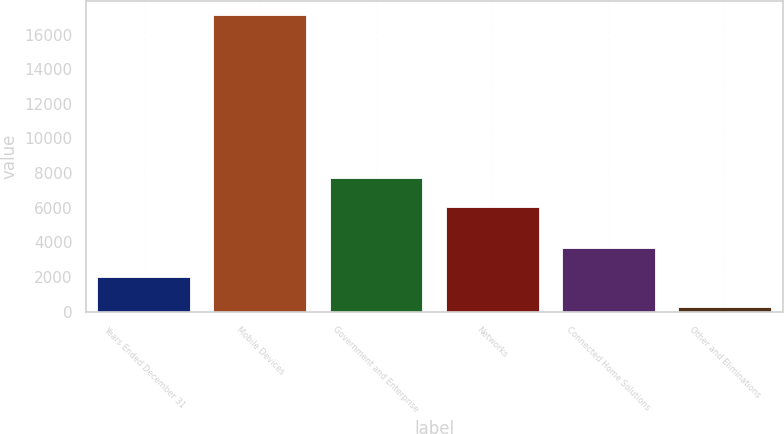Convert chart. <chart><loc_0><loc_0><loc_500><loc_500><bar_chart><fcel>Years Ended December 31<fcel>Mobile Devices<fcel>Government and Enterprise<fcel>Networks<fcel>Connected Home Solutions<fcel>Other and Eliminations<nl><fcel>2004<fcel>17108<fcel>7711.5<fcel>6026<fcel>3689.5<fcel>253<nl></chart> 